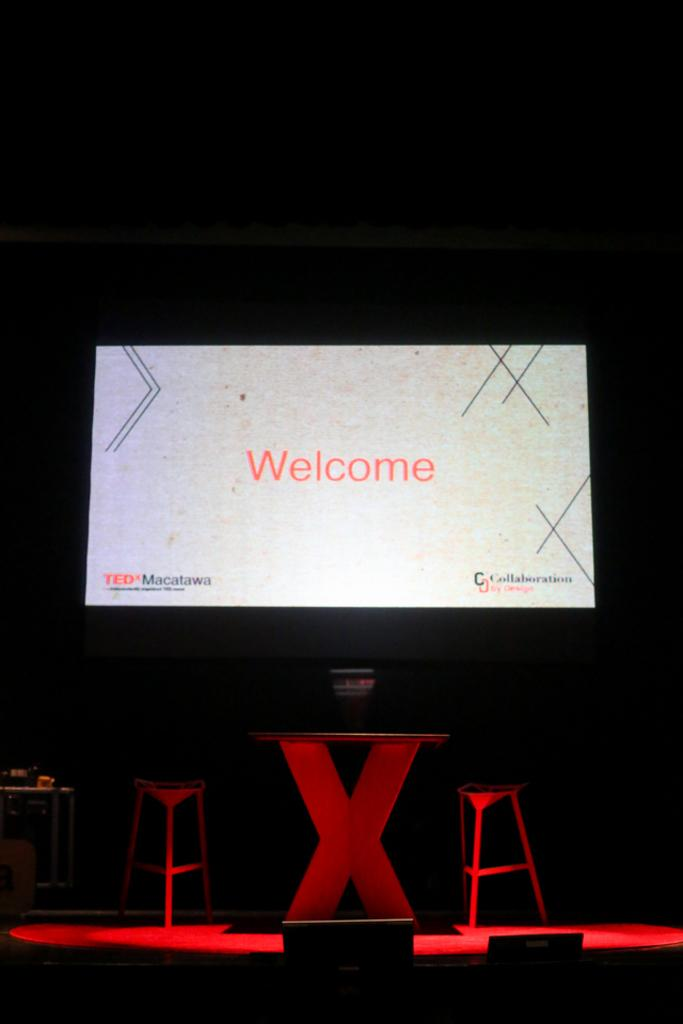<image>
Share a concise interpretation of the image provided. A PROJECTION SCREEN ABOVE TWO RED CHAIRS AND TABLE DISPLAYING WELCOME 